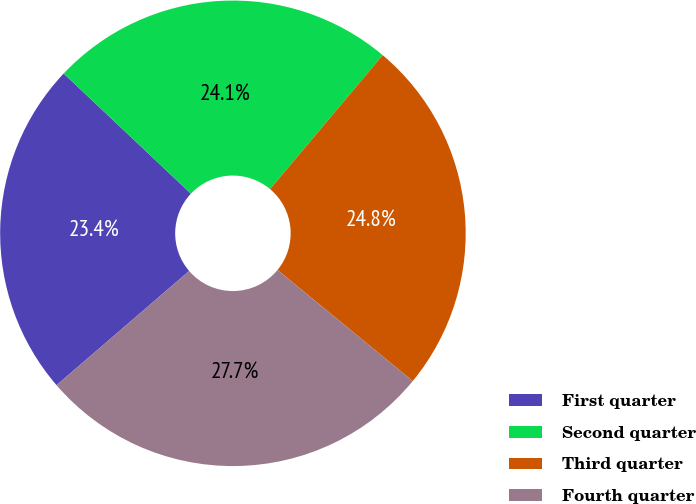Convert chart. <chart><loc_0><loc_0><loc_500><loc_500><pie_chart><fcel>First quarter<fcel>Second quarter<fcel>Third quarter<fcel>Fourth quarter<nl><fcel>23.36%<fcel>24.09%<fcel>24.82%<fcel>27.74%<nl></chart> 